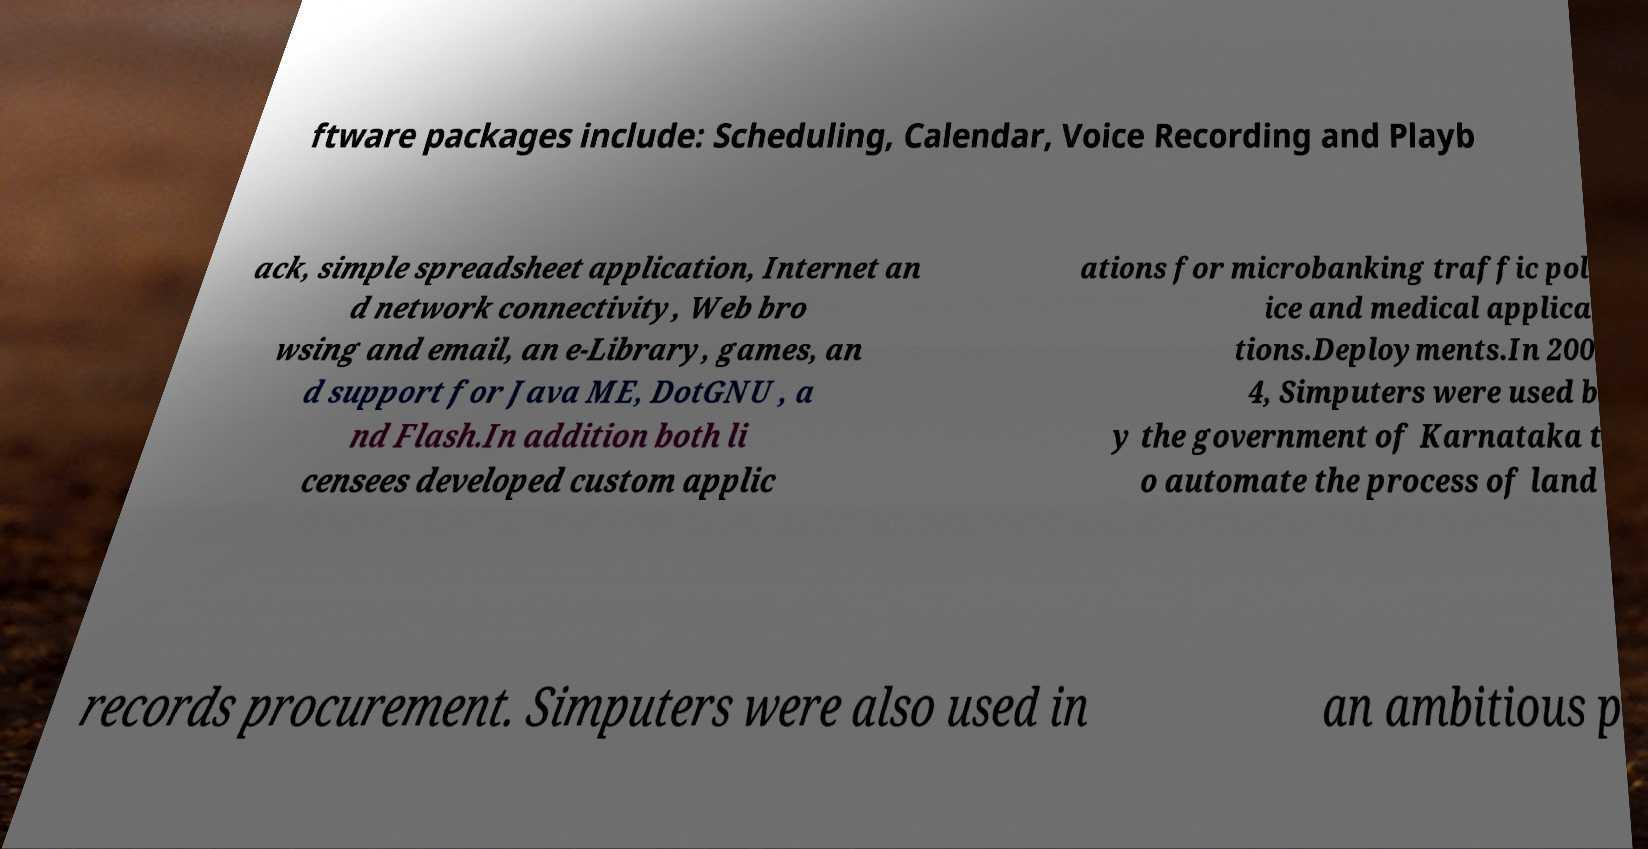Please read and relay the text visible in this image. What does it say? ftware packages include: Scheduling, Calendar, Voice Recording and Playb ack, simple spreadsheet application, Internet an d network connectivity, Web bro wsing and email, an e-Library, games, an d support for Java ME, DotGNU , a nd Flash.In addition both li censees developed custom applic ations for microbanking traffic pol ice and medical applica tions.Deployments.In 200 4, Simputers were used b y the government of Karnataka t o automate the process of land records procurement. Simputers were also used in an ambitious p 